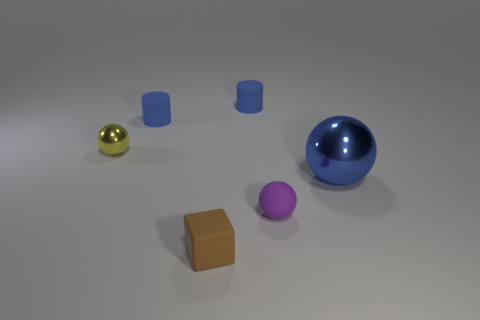What color is the ball in front of the shiny ball that is in front of the yellow metal object?
Give a very brief answer. Purple. Are there any other rubber blocks that have the same color as the cube?
Give a very brief answer. No. There is a metal sphere that is the same size as the brown thing; what color is it?
Ensure brevity in your answer.  Yellow. Do the small sphere in front of the tiny yellow thing and the big blue thing have the same material?
Your answer should be compact. No. Is there a sphere behind the ball that is behind the metal sphere in front of the tiny yellow thing?
Make the answer very short. No. Do the large blue metallic object that is in front of the small shiny object and the purple thing have the same shape?
Your answer should be compact. Yes. The thing that is in front of the tiny ball in front of the big object is what shape?
Make the answer very short. Cube. There is a matte cylinder that is behind the blue cylinder in front of the blue cylinder that is to the right of the brown cube; what is its size?
Provide a succinct answer. Small. What is the color of the other matte thing that is the same shape as the large thing?
Your answer should be compact. Purple. Do the blue shiny thing and the yellow metal thing have the same size?
Your response must be concise. No. 